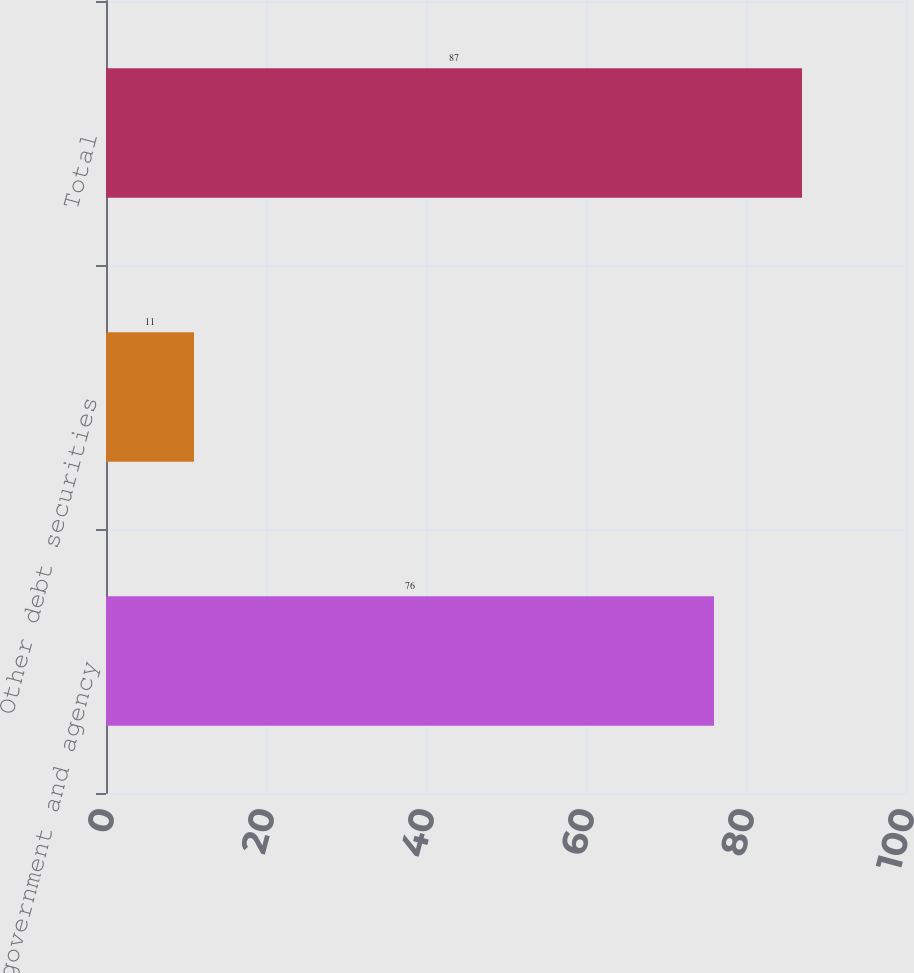<chart> <loc_0><loc_0><loc_500><loc_500><bar_chart><fcel>US government and agency<fcel>Other debt securities<fcel>Total<nl><fcel>76<fcel>11<fcel>87<nl></chart> 